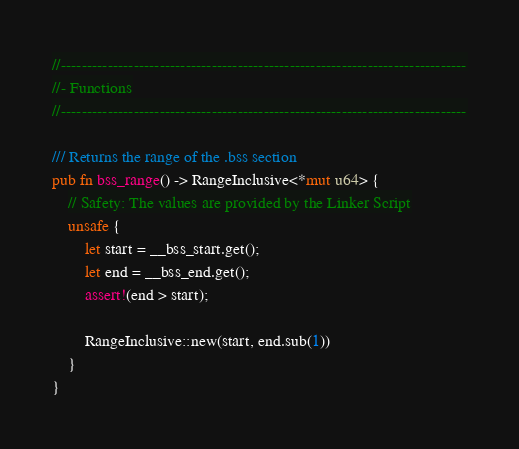Convert code to text. <code><loc_0><loc_0><loc_500><loc_500><_Rust_>
//------------------------------------------------------------------------------
//- Functions
//------------------------------------------------------------------------------

/// Returns the range of the .bss section
pub fn bss_range() -> RangeInclusive<*mut u64> {
    // Safety: The values are provided by the Linker Script
    unsafe {
        let start = __bss_start.get();
        let end = __bss_end.get();
        assert!(end > start);

        RangeInclusive::new(start, end.sub(1))
    }
}
</code> 